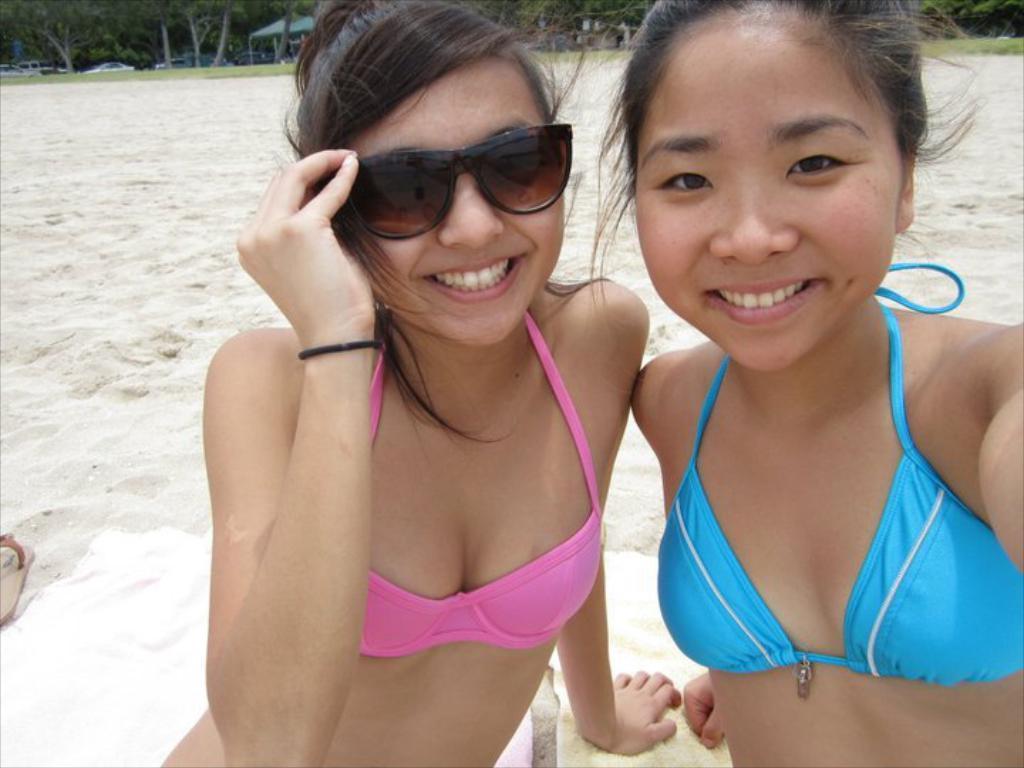Please provide a concise description of this image. The two girls in front of the picture are sitting on the white cloth. The girl on the left side is wearing goggles. Both of them are smiling. Behind them, we see sand. On the left side, we see a sandal. We see cars moving in the background. There are trees and a tent in the background. 